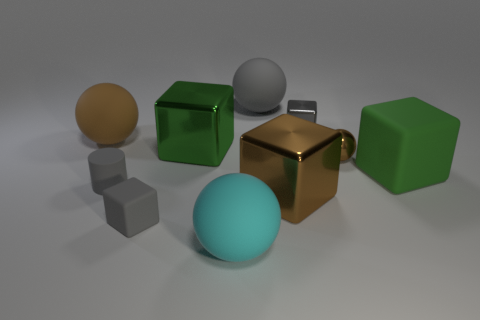Subtract all gray rubber blocks. How many blocks are left? 4 Subtract all red cylinders. How many green cubes are left? 2 Subtract 1 cubes. How many cubes are left? 4 Subtract all gray balls. How many balls are left? 3 Subtract all purple blocks. Subtract all green spheres. How many blocks are left? 5 Subtract all spheres. How many objects are left? 6 Add 9 brown metal spheres. How many brown metal spheres exist? 10 Subtract 0 blue balls. How many objects are left? 10 Subtract all red metallic balls. Subtract all small cylinders. How many objects are left? 9 Add 8 big matte blocks. How many big matte blocks are left? 9 